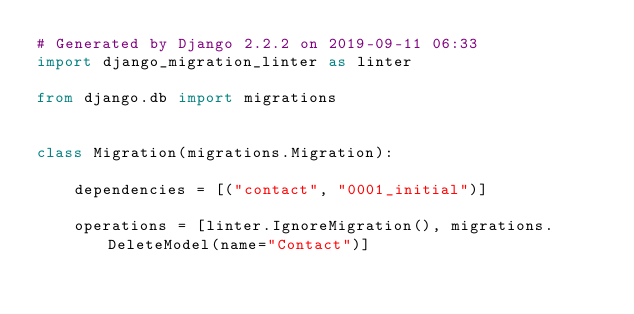Convert code to text. <code><loc_0><loc_0><loc_500><loc_500><_Python_># Generated by Django 2.2.2 on 2019-09-11 06:33
import django_migration_linter as linter

from django.db import migrations


class Migration(migrations.Migration):

    dependencies = [("contact", "0001_initial")]

    operations = [linter.IgnoreMigration(), migrations.DeleteModel(name="Contact")]
</code> 